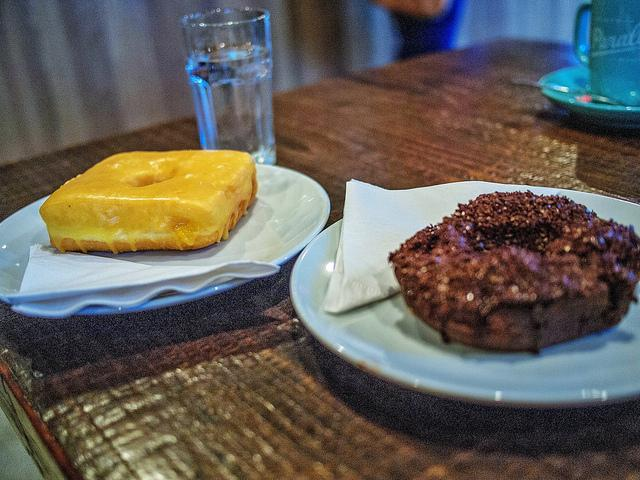What material would the plates be made of? Please explain your reasoning. ceramic. The plates are hard and shiny. 